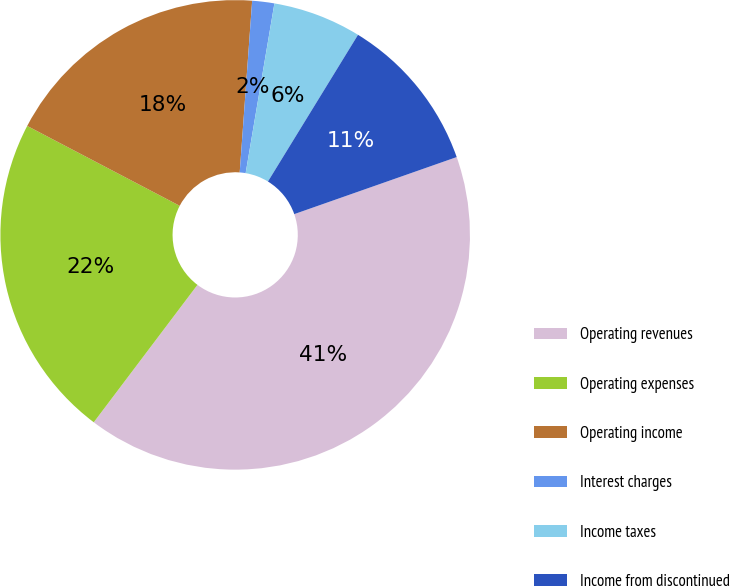Convert chart. <chart><loc_0><loc_0><loc_500><loc_500><pie_chart><fcel>Operating revenues<fcel>Operating expenses<fcel>Operating income<fcel>Interest charges<fcel>Income taxes<fcel>Income from discontinued<nl><fcel>40.66%<fcel>22.39%<fcel>18.47%<fcel>1.52%<fcel>6.09%<fcel>10.86%<nl></chart> 